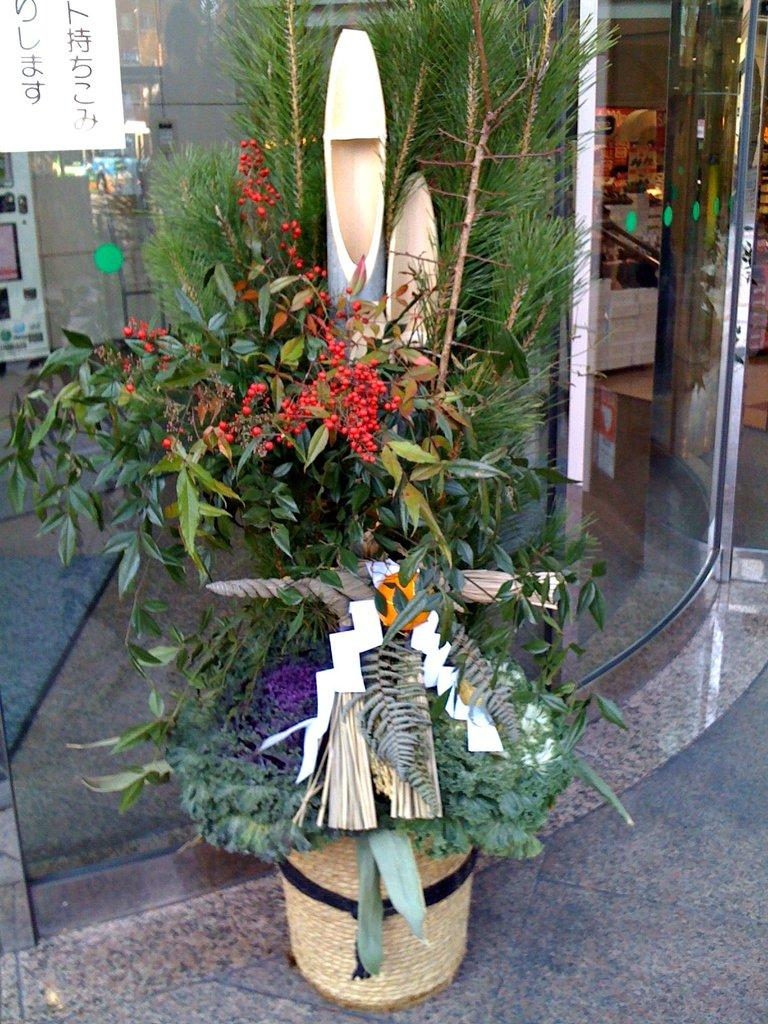What can be seen on the floor in the image? The floor is visible in the image, but no specific details are provided about what is on the floor. What type of vegetation is present in the image? There are plants in the image. What is placed on the plants? There are objects on the plants. What can be seen on the glass in the image? There are reflections on the glass in the image. What type of boot can be seen in the image? There is no boot present in the image. What kind of noise can be heard coming from the plants in the image? There is no noise coming from the plants in the image, as plants do not make sounds. 